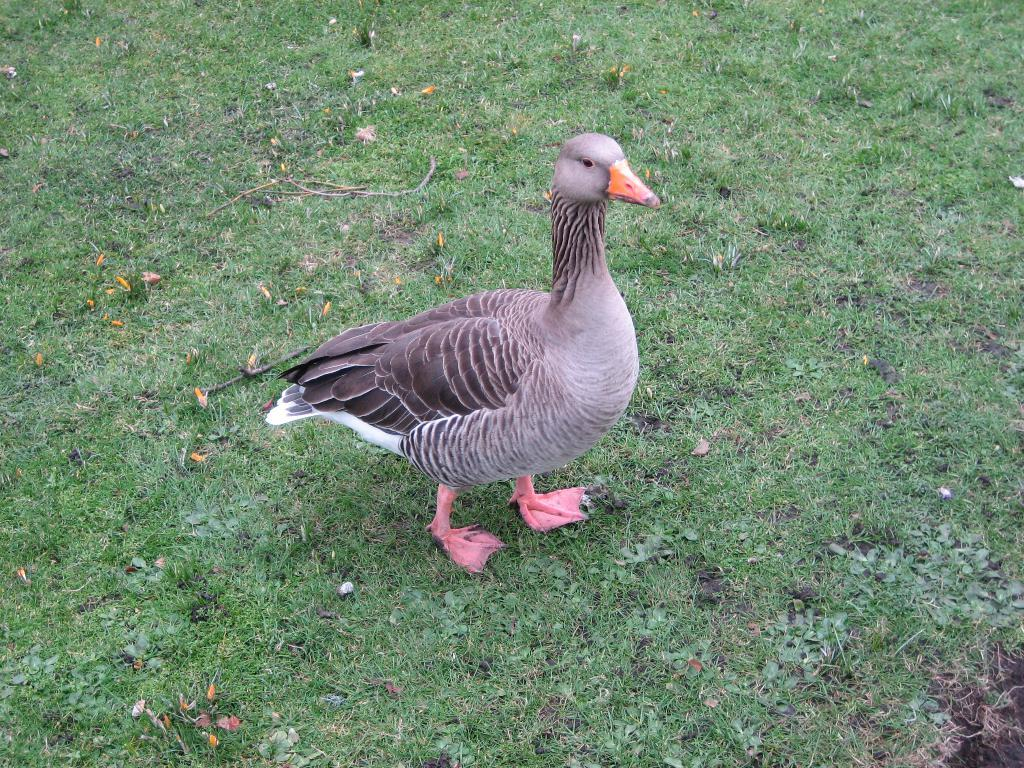What type of animal is on the ground in the image? There is a bird on the ground in the image. What is the surface on which the bird is standing? There is grass on the ground in the image. What property does the bird have in the image? There is no information about the bird's property in the image. What is the bird reading in the image? There is no indication that the bird is reading anything in the image. 